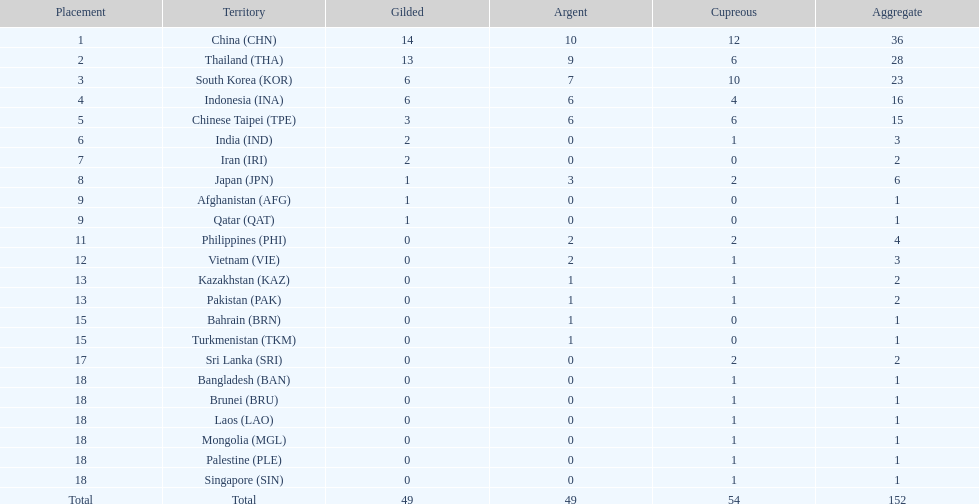What was the number of medals earned by indonesia (ina) ? 16. 